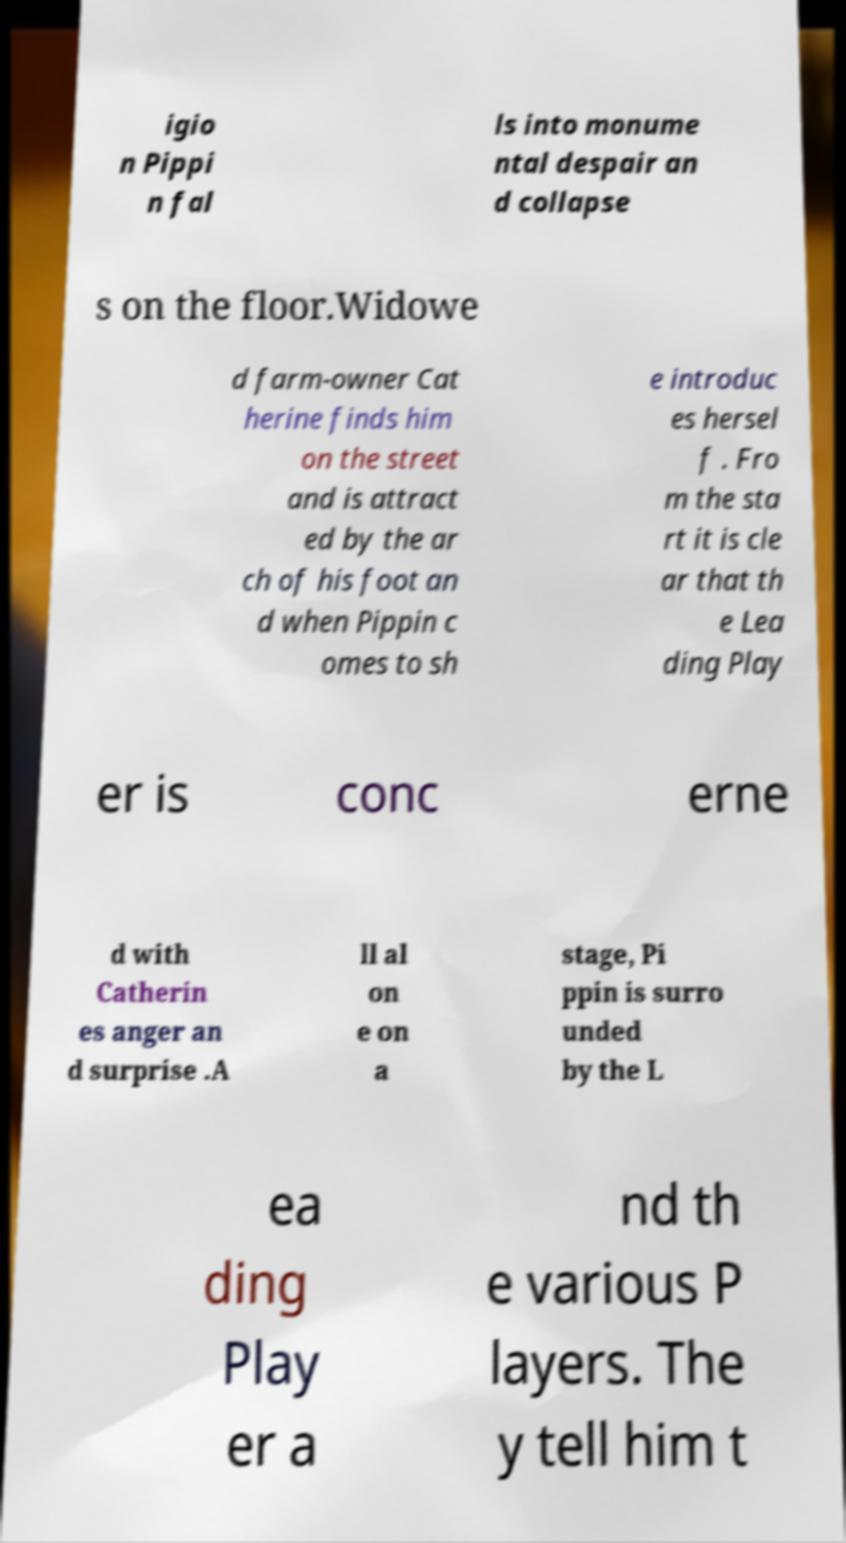Can you accurately transcribe the text from the provided image for me? igio n Pippi n fal ls into monume ntal despair an d collapse s on the floor.Widowe d farm-owner Cat herine finds him on the street and is attract ed by the ar ch of his foot an d when Pippin c omes to sh e introduc es hersel f . Fro m the sta rt it is cle ar that th e Lea ding Play er is conc erne d with Catherin es anger an d surprise .A ll al on e on a stage, Pi ppin is surro unded by the L ea ding Play er a nd th e various P layers. The y tell him t 